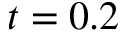Convert formula to latex. <formula><loc_0><loc_0><loc_500><loc_500>t = 0 . 2</formula> 